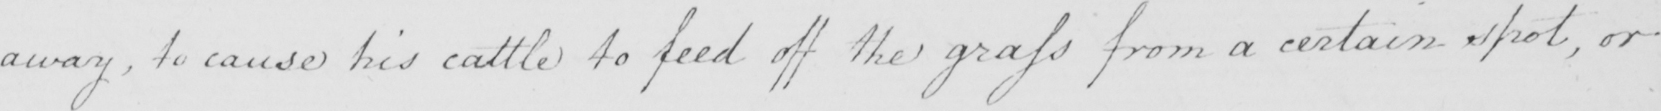Can you read and transcribe this handwriting? away , to cause his cattle to feed off the grass from a certain spot , or 